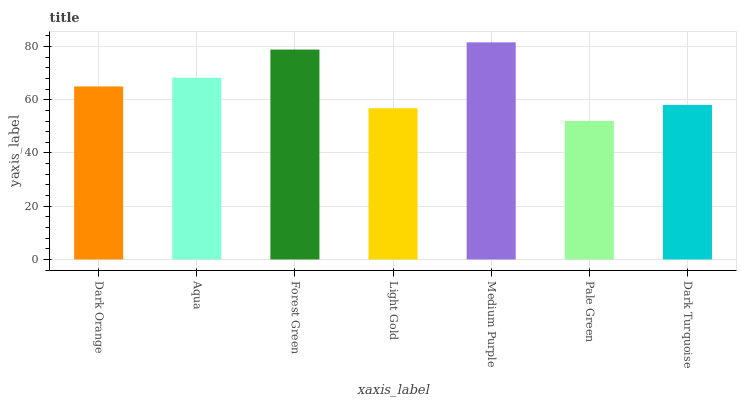Is Pale Green the minimum?
Answer yes or no. Yes. Is Medium Purple the maximum?
Answer yes or no. Yes. Is Aqua the minimum?
Answer yes or no. No. Is Aqua the maximum?
Answer yes or no. No. Is Aqua greater than Dark Orange?
Answer yes or no. Yes. Is Dark Orange less than Aqua?
Answer yes or no. Yes. Is Dark Orange greater than Aqua?
Answer yes or no. No. Is Aqua less than Dark Orange?
Answer yes or no. No. Is Dark Orange the high median?
Answer yes or no. Yes. Is Dark Orange the low median?
Answer yes or no. Yes. Is Medium Purple the high median?
Answer yes or no. No. Is Pale Green the low median?
Answer yes or no. No. 